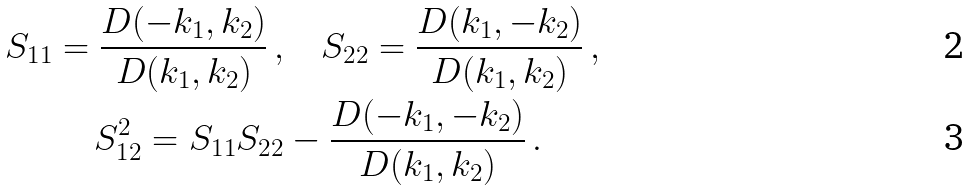<formula> <loc_0><loc_0><loc_500><loc_500>S _ { 1 1 } = \frac { D ( - k _ { 1 } , k _ { 2 } ) } { D ( k _ { 1 } , k _ { 2 } ) } \, , & \quad S _ { 2 2 } = \frac { D ( k _ { 1 } , - k _ { 2 } ) } { D ( k _ { 1 } , k _ { 2 } ) } \, , \\ S _ { 1 2 } ^ { 2 } = S _ { 1 1 } S _ { 2 2 } & - \frac { D ( - k _ { 1 } , - k _ { 2 } ) } { D ( k _ { 1 } , k _ { 2 } ) } \, .</formula> 